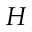<formula> <loc_0><loc_0><loc_500><loc_500>H</formula> 